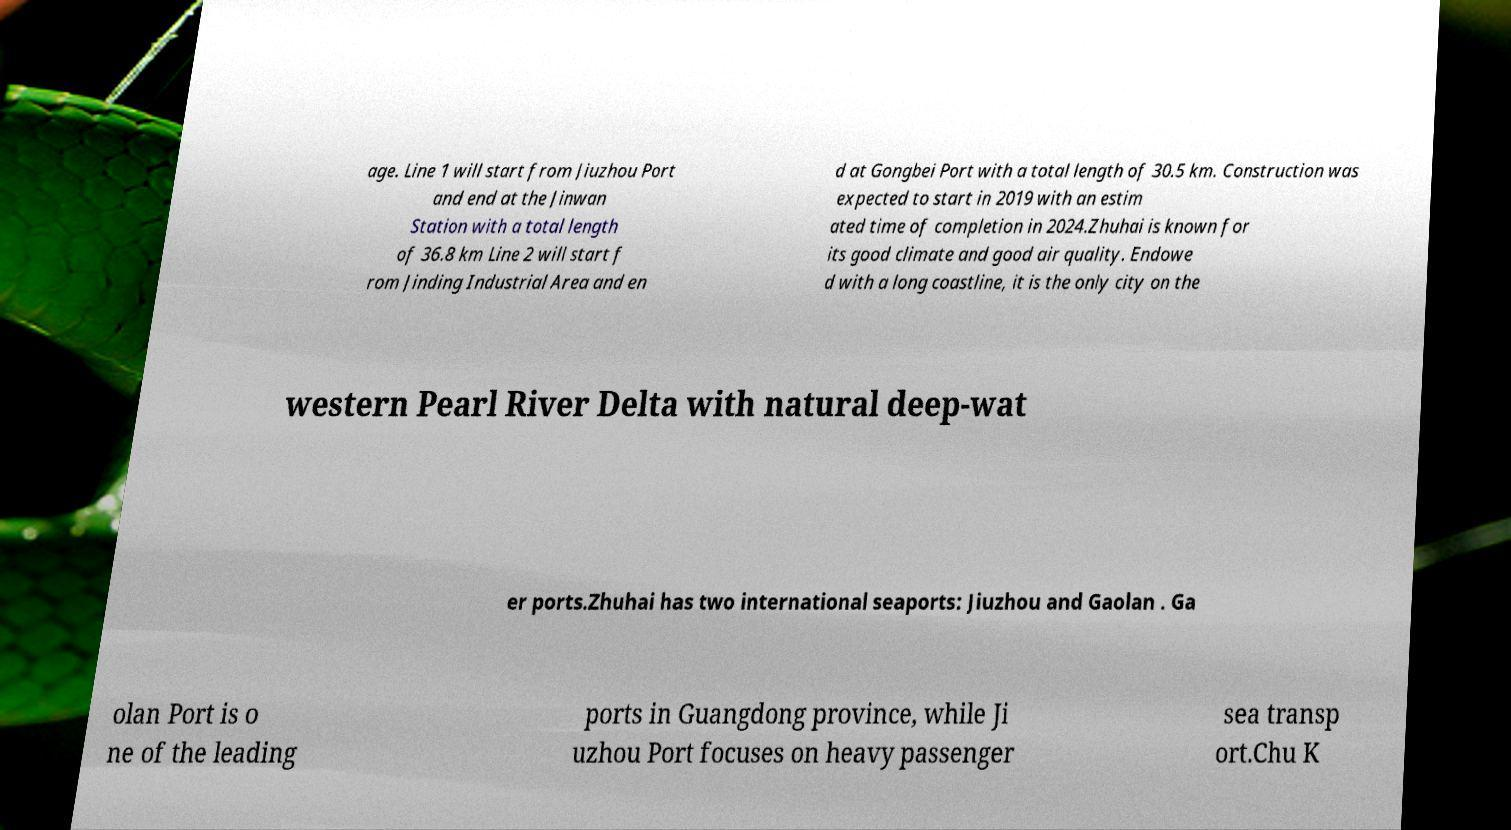What messages or text are displayed in this image? I need them in a readable, typed format. age. Line 1 will start from Jiuzhou Port and end at the Jinwan Station with a total length of 36.8 km Line 2 will start f rom Jinding Industrial Area and en d at Gongbei Port with a total length of 30.5 km. Construction was expected to start in 2019 with an estim ated time of completion in 2024.Zhuhai is known for its good climate and good air quality. Endowe d with a long coastline, it is the only city on the western Pearl River Delta with natural deep-wat er ports.Zhuhai has two international seaports: Jiuzhou and Gaolan . Ga olan Port is o ne of the leading ports in Guangdong province, while Ji uzhou Port focuses on heavy passenger sea transp ort.Chu K 